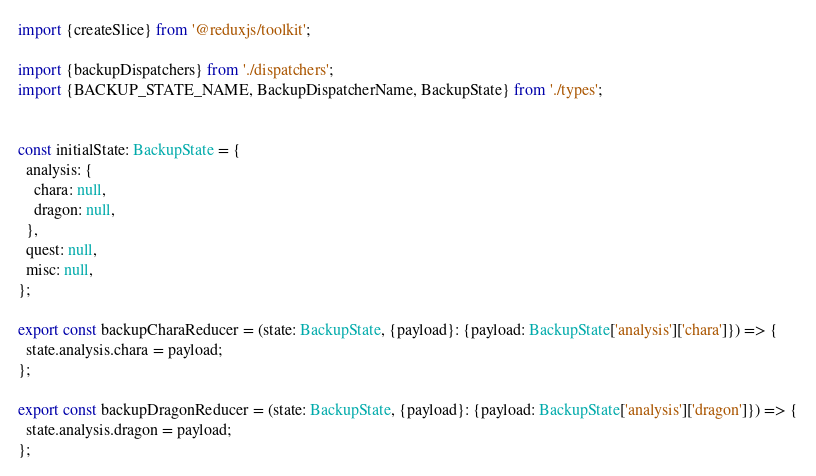Convert code to text. <code><loc_0><loc_0><loc_500><loc_500><_TypeScript_>import {createSlice} from '@reduxjs/toolkit';

import {backupDispatchers} from './dispatchers';
import {BACKUP_STATE_NAME, BackupDispatcherName, BackupState} from './types';


const initialState: BackupState = {
  analysis: {
    chara: null,
    dragon: null,
  },
  quest: null,
  misc: null,
};

export const backupCharaReducer = (state: BackupState, {payload}: {payload: BackupState['analysis']['chara']}) => {
  state.analysis.chara = payload;
};

export const backupDragonReducer = (state: BackupState, {payload}: {payload: BackupState['analysis']['dragon']}) => {
  state.analysis.dragon = payload;
};
</code> 